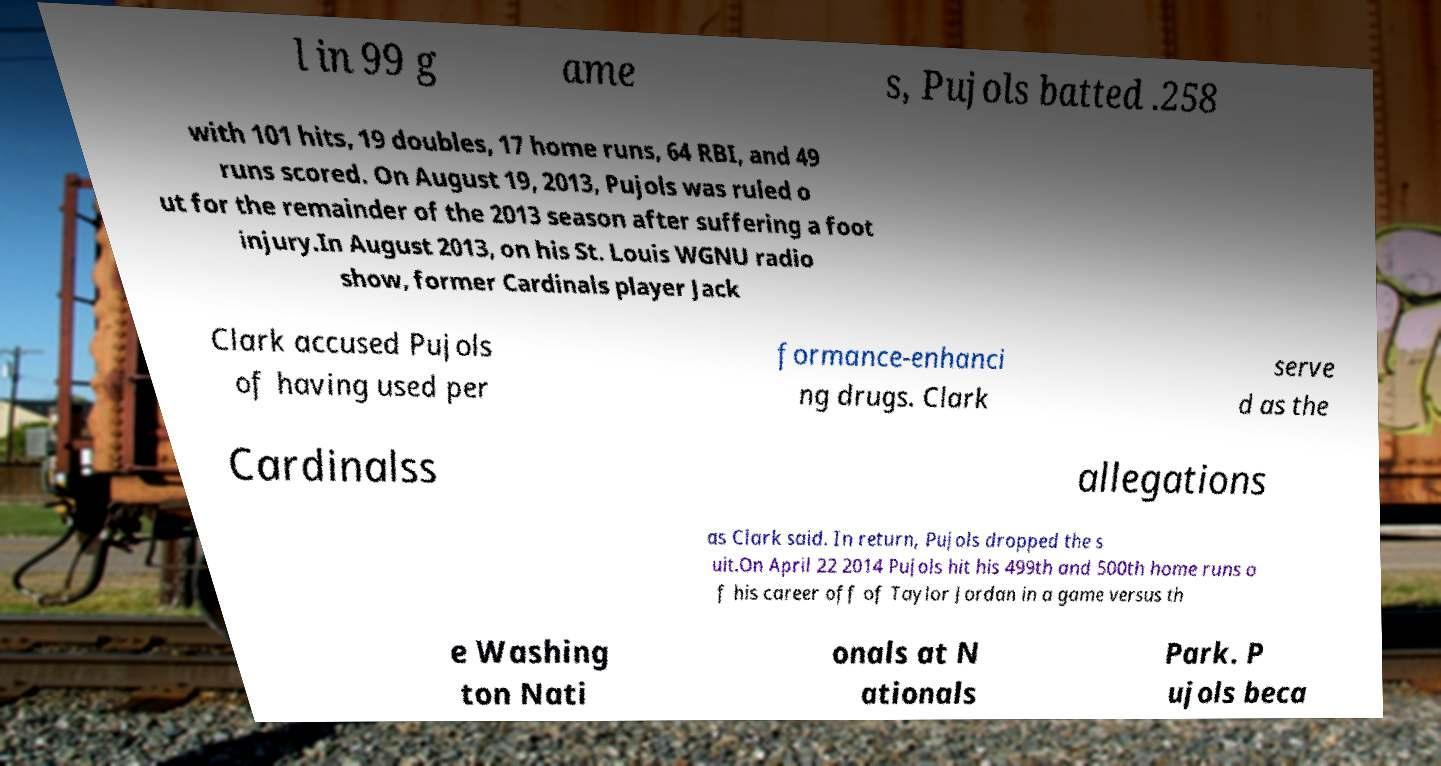Can you read and provide the text displayed in the image?This photo seems to have some interesting text. Can you extract and type it out for me? l in 99 g ame s, Pujols batted .258 with 101 hits, 19 doubles, 17 home runs, 64 RBI, and 49 runs scored. On August 19, 2013, Pujols was ruled o ut for the remainder of the 2013 season after suffering a foot injury.In August 2013, on his St. Louis WGNU radio show, former Cardinals player Jack Clark accused Pujols of having used per formance-enhanci ng drugs. Clark serve d as the Cardinalss allegations as Clark said. In return, Pujols dropped the s uit.On April 22 2014 Pujols hit his 499th and 500th home runs o f his career off of Taylor Jordan in a game versus th e Washing ton Nati onals at N ationals Park. P ujols beca 